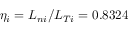<formula> <loc_0><loc_0><loc_500><loc_500>\eta _ { i } = L _ { n i } / L _ { T i } = 0 . 8 3 2 4</formula> 